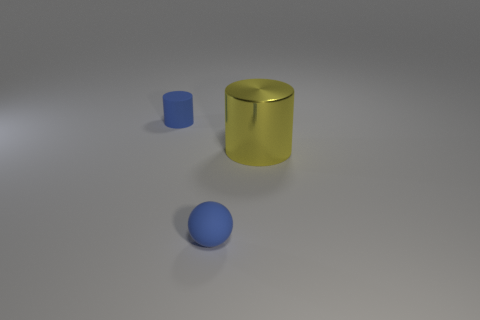Add 1 shiny cylinders. How many objects exist? 4 Subtract all cylinders. How many objects are left? 1 Subtract 0 red blocks. How many objects are left? 3 Subtract all yellow matte objects. Subtract all matte spheres. How many objects are left? 2 Add 3 matte balls. How many matte balls are left? 4 Add 2 cyan matte cubes. How many cyan matte cubes exist? 2 